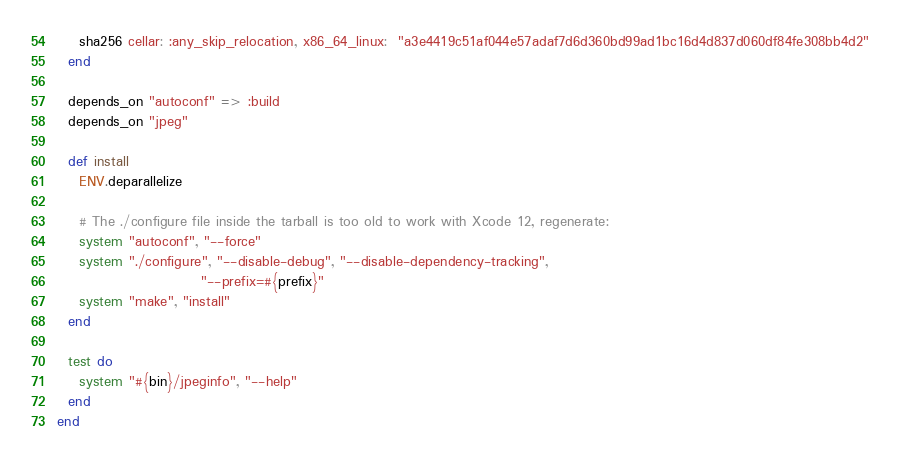<code> <loc_0><loc_0><loc_500><loc_500><_Ruby_>    sha256 cellar: :any_skip_relocation, x86_64_linux:  "a3e4419c51af044e57adaf7d6d360bd99ad1bc16d4d837d060df84fe308bb4d2"
  end

  depends_on "autoconf" => :build
  depends_on "jpeg"

  def install
    ENV.deparallelize

    # The ./configure file inside the tarball is too old to work with Xcode 12, regenerate:
    system "autoconf", "--force"
    system "./configure", "--disable-debug", "--disable-dependency-tracking",
                          "--prefix=#{prefix}"
    system "make", "install"
  end

  test do
    system "#{bin}/jpeginfo", "--help"
  end
end
</code> 